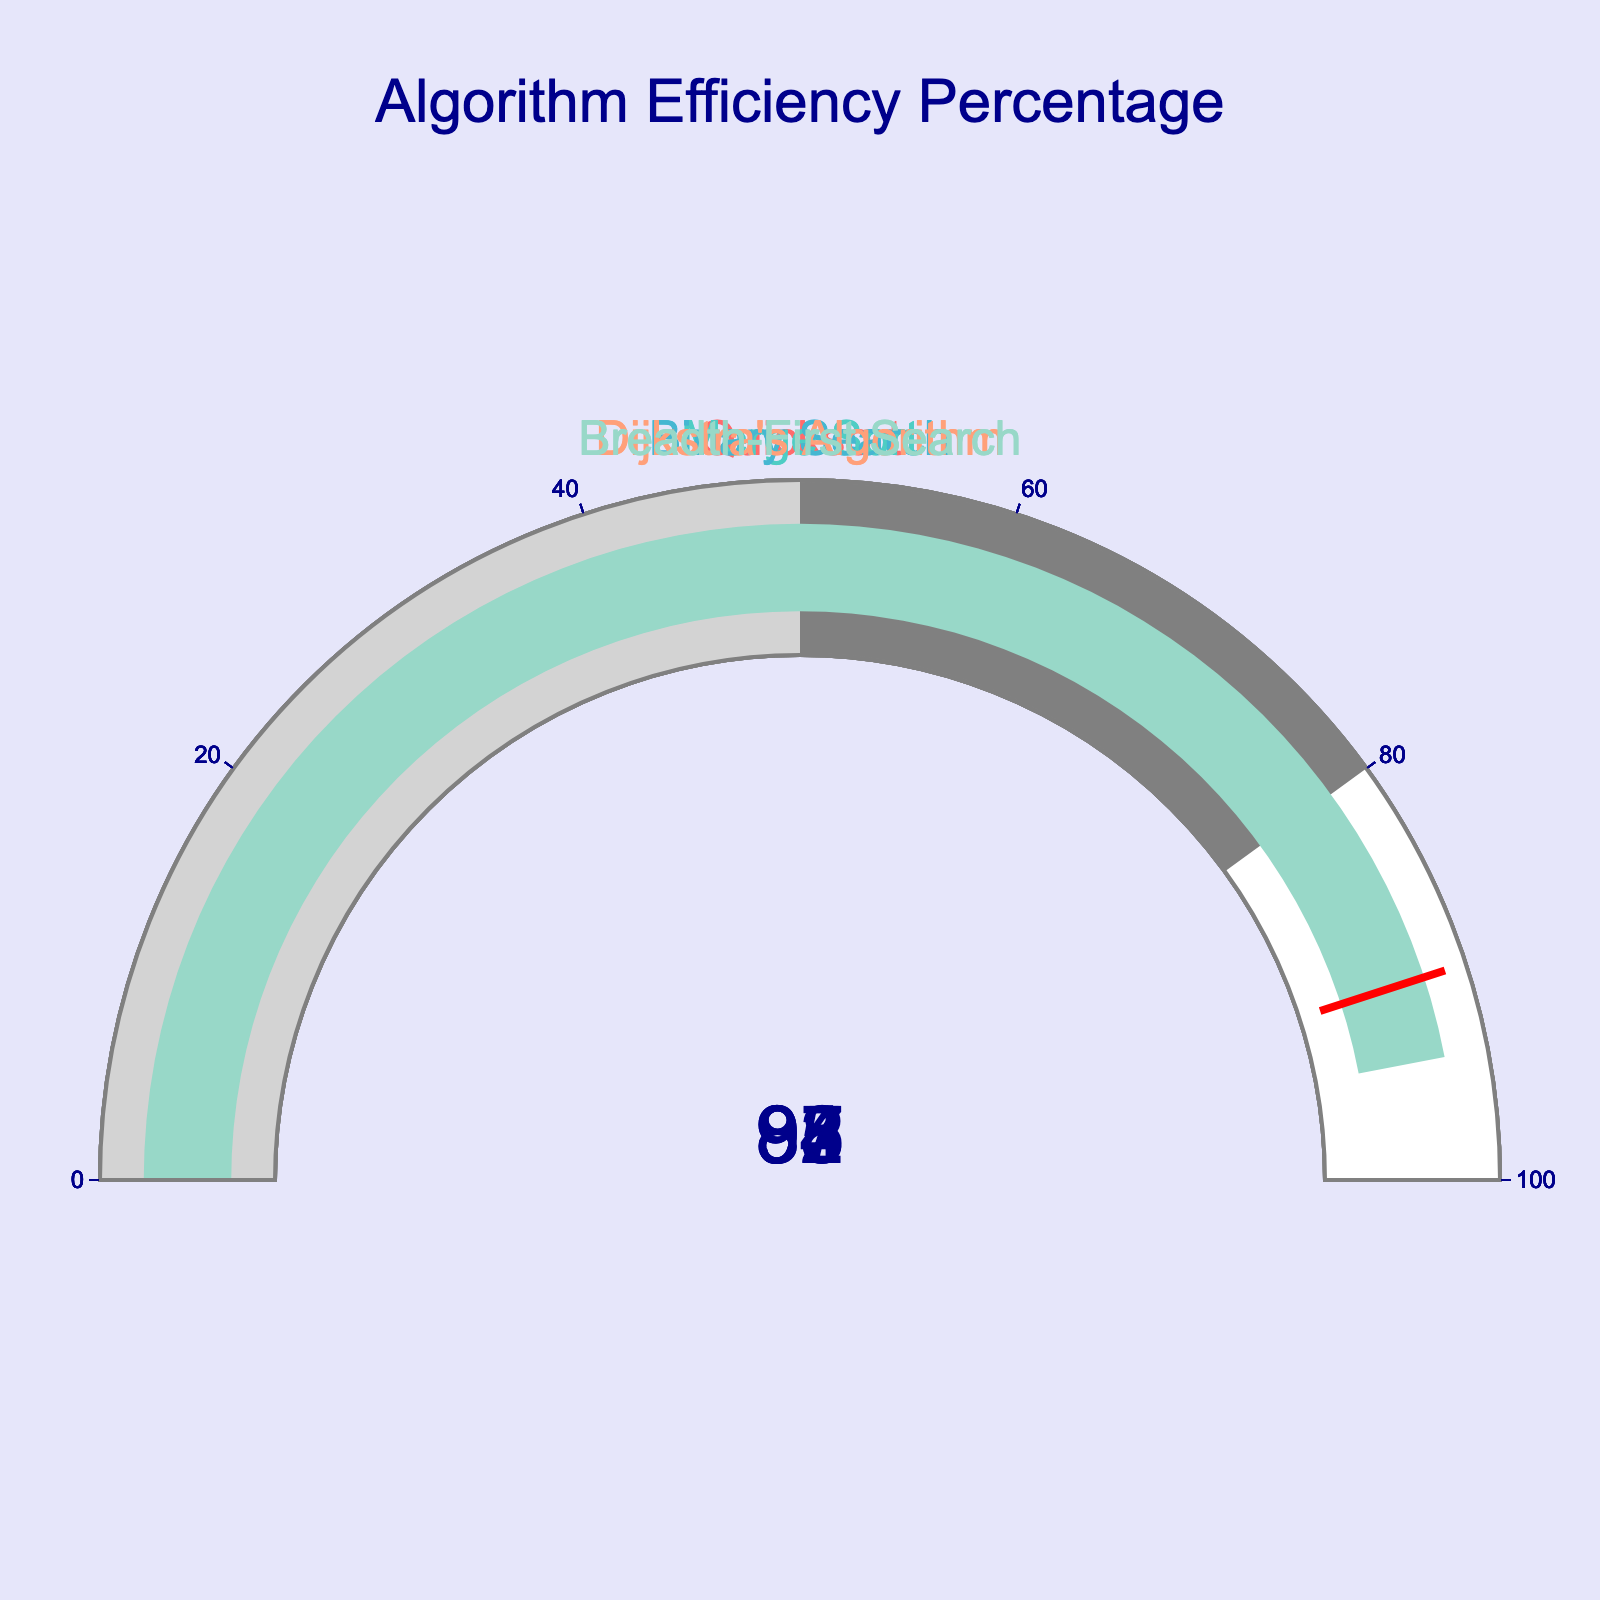what is the efficiency percentage of Quicksort? The gauge chart displays the efficiency of Quicksort as indicated by the number on the gauge. It shows 87%.
Answer: 87% what's the color of the bar representing Merge Sort? The color of the bar for each algorithm is visually distinct. The Merge Sort bar is shown in the plot in a color among ['#FF6B6B', '#4ECDC4', '#45B7D1', '#FFA07A', '#98D8C8']. Original colors are transformed visually; for Merge Sort, it is the second color, which shows as teal/green.
Answer: teal/green what's the average efficiency of all algorithms? To find the average efficiency, sum all individual efficiencies (87 + 92 + 98 + 85 + 94) = 456. Then divide by the number of algorithms, which is 5. So, 456 / 5 = 91.2
Answer: 91.2 which algorithm has the highest efficiency percentage? By comparing each gauge's displayed number, Binary Search has the highest efficiency with 98%.
Answer: Binary Search which algorithms have a higher efficiency percentage than Dijkstra's Algorithm? Dijkstra’s Algorithm has an efficiency percentage of 85%. Algorithms with higher efficiencies are Quicksort (87%), Merge Sort (92%), Binary Search (98%), and Breadth-First Search (94%).
Answer: Quicksort, Merge Sort, Binary Search, Breadth-First Search which algorithms have efficiency greater than 90% but less than 95%? By evaluating each displayed number, the algorithms within this range are Merge Sort (92%) and Breadth-First Search (94%).
Answer: Merge Sort, Breadth-First Search what's the difference in efficiency between Binary Search and Quicksort? The efficiency of Binary Search is 98% and Quicksort is 87%. The difference is 98% - 87% = 11%.
Answer: 11% which algorithm falls below the 90% efficiency threshold according to the gauge chart's {threshold} value? The threshold line is set at 90%, and algorithms below this line are Quicksort (87%) and Dijkstra’s Algorithm (85%).
Answer: Quicksort, Dijkstra's Algorithm 